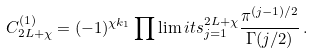Convert formula to latex. <formula><loc_0><loc_0><loc_500><loc_500>C _ { 2 L + \chi } ^ { ( 1 ) } = ( - 1 ) ^ { \chi k _ { 1 } } \prod \lim i t s _ { j = 1 } ^ { 2 L + \chi } \frac { \pi ^ { ( j - 1 ) / 2 } } { \Gamma ( j / 2 ) } \, .</formula> 